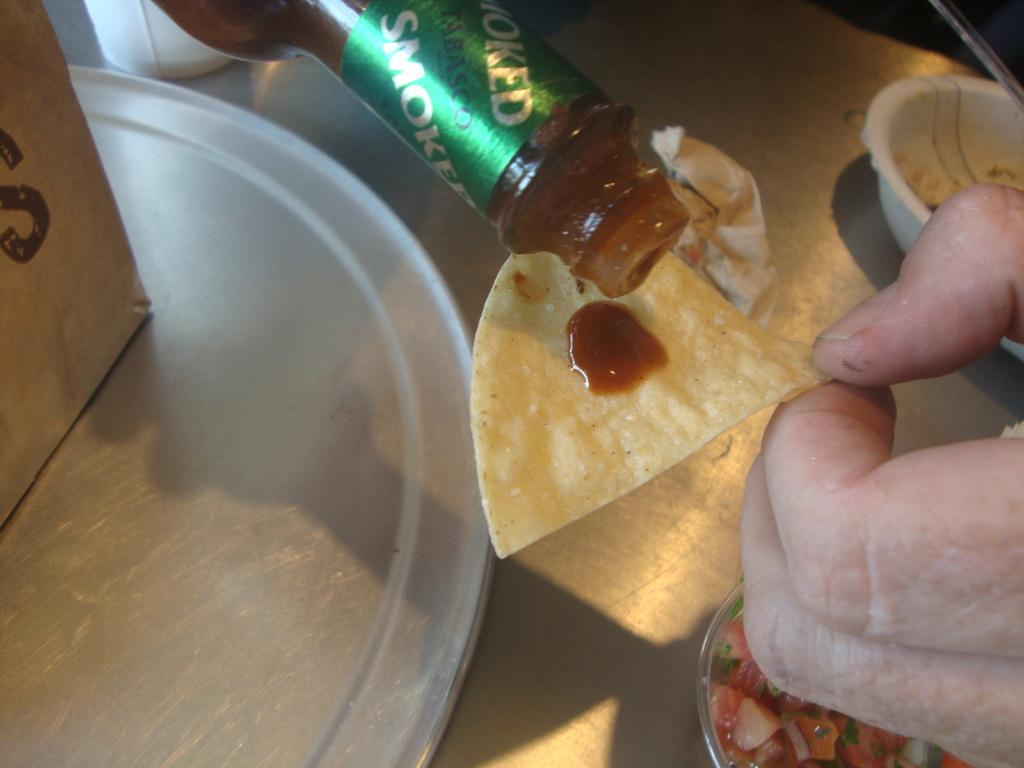What object is being used to pour sauce in the image? There is a sauce bottle in the image, and a man is pouring sauce. What is located at the right side of the image? There is a bowl at the right side of the image. What other kitchen items can be seen in the image? Other kitchenware is present in the image. What type of rock is being used as a cutting board in the image? There is no rock or cutting board present in the image. Is there a crib visible in the image? No, there is no crib present in the image. 